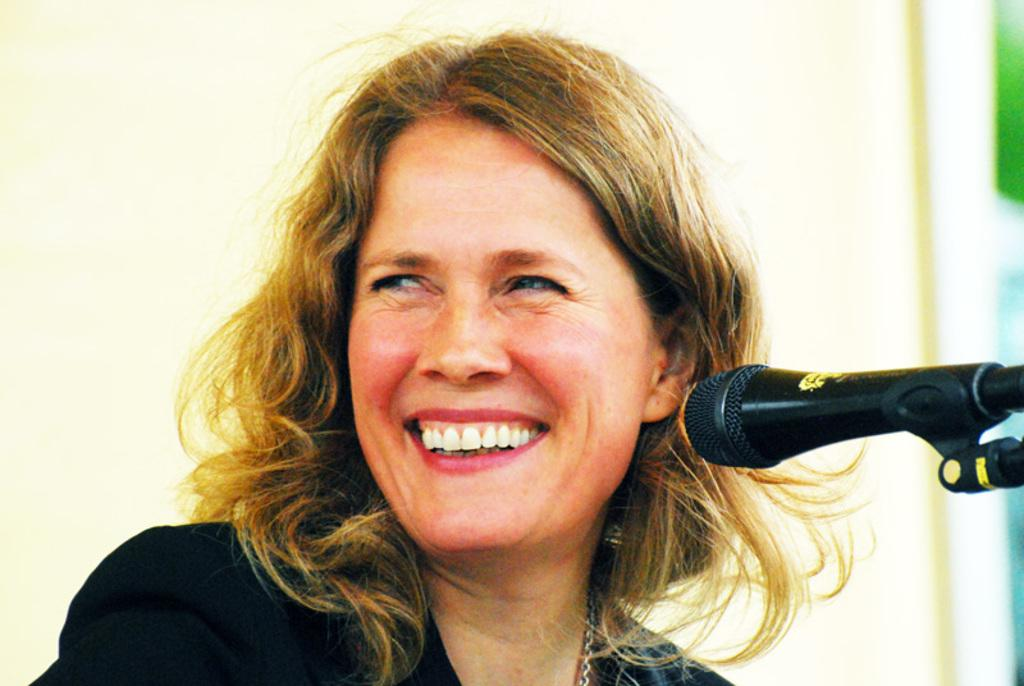What is the main object in the middle of the image? There is a microphone in the middle of the image. Who is present in the image? There is a woman in the image. What expression does the woman have? The woman is smiling. What can be seen in the background of the image? There is a wall in the background of the image. What type of umbrella is being used to shield the microphone from the rain in the image? There is no umbrella present in the image, and the microphone is not being shielded from the rain. 